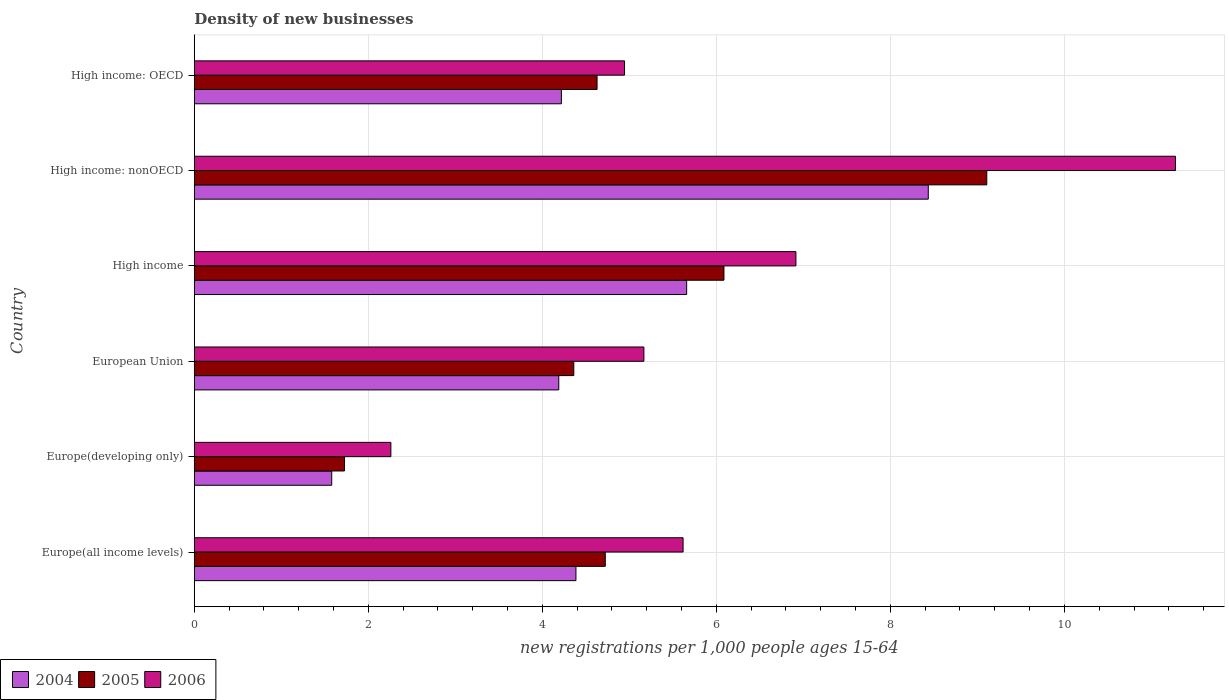How many different coloured bars are there?
Provide a short and direct response. 3. Are the number of bars per tick equal to the number of legend labels?
Give a very brief answer. Yes. Are the number of bars on each tick of the Y-axis equal?
Your answer should be very brief. Yes. What is the label of the 5th group of bars from the top?
Offer a very short reply. Europe(developing only). What is the number of new registrations in 2004 in European Union?
Give a very brief answer. 4.19. Across all countries, what is the maximum number of new registrations in 2004?
Offer a very short reply. 8.44. Across all countries, what is the minimum number of new registrations in 2004?
Your response must be concise. 1.58. In which country was the number of new registrations in 2006 maximum?
Keep it short and to the point. High income: nonOECD. In which country was the number of new registrations in 2006 minimum?
Your answer should be very brief. Europe(developing only). What is the total number of new registrations in 2006 in the graph?
Provide a short and direct response. 36.18. What is the difference between the number of new registrations in 2004 in Europe(developing only) and that in European Union?
Your answer should be compact. -2.61. What is the difference between the number of new registrations in 2004 in European Union and the number of new registrations in 2006 in High income?
Your answer should be compact. -2.73. What is the average number of new registrations in 2006 per country?
Make the answer very short. 6.03. What is the difference between the number of new registrations in 2004 and number of new registrations in 2006 in Europe(all income levels)?
Offer a terse response. -1.23. In how many countries, is the number of new registrations in 2004 greater than 2.8 ?
Your response must be concise. 5. What is the ratio of the number of new registrations in 2005 in Europe(developing only) to that in High income: OECD?
Provide a short and direct response. 0.37. Is the number of new registrations in 2006 in Europe(all income levels) less than that in Europe(developing only)?
Your response must be concise. No. What is the difference between the highest and the second highest number of new registrations in 2005?
Provide a short and direct response. 3.02. What is the difference between the highest and the lowest number of new registrations in 2005?
Your answer should be compact. 7.38. In how many countries, is the number of new registrations in 2005 greater than the average number of new registrations in 2005 taken over all countries?
Offer a very short reply. 2. What does the 3rd bar from the bottom in Europe(all income levels) represents?
Your answer should be compact. 2006. Is it the case that in every country, the sum of the number of new registrations in 2006 and number of new registrations in 2004 is greater than the number of new registrations in 2005?
Provide a succinct answer. Yes. Are all the bars in the graph horizontal?
Your answer should be very brief. Yes. How many countries are there in the graph?
Offer a terse response. 6. What is the difference between two consecutive major ticks on the X-axis?
Give a very brief answer. 2. Does the graph contain any zero values?
Ensure brevity in your answer.  No. Does the graph contain grids?
Give a very brief answer. Yes. How many legend labels are there?
Your answer should be very brief. 3. What is the title of the graph?
Make the answer very short. Density of new businesses. What is the label or title of the X-axis?
Give a very brief answer. New registrations per 1,0 people ages 15-64. What is the label or title of the Y-axis?
Make the answer very short. Country. What is the new registrations per 1,000 people ages 15-64 in 2004 in Europe(all income levels)?
Make the answer very short. 4.39. What is the new registrations per 1,000 people ages 15-64 of 2005 in Europe(all income levels)?
Ensure brevity in your answer.  4.72. What is the new registrations per 1,000 people ages 15-64 in 2006 in Europe(all income levels)?
Offer a very short reply. 5.62. What is the new registrations per 1,000 people ages 15-64 of 2004 in Europe(developing only)?
Your answer should be compact. 1.58. What is the new registrations per 1,000 people ages 15-64 of 2005 in Europe(developing only)?
Offer a terse response. 1.73. What is the new registrations per 1,000 people ages 15-64 of 2006 in Europe(developing only)?
Give a very brief answer. 2.26. What is the new registrations per 1,000 people ages 15-64 in 2004 in European Union?
Your response must be concise. 4.19. What is the new registrations per 1,000 people ages 15-64 in 2005 in European Union?
Your answer should be compact. 4.36. What is the new registrations per 1,000 people ages 15-64 of 2006 in European Union?
Provide a short and direct response. 5.17. What is the new registrations per 1,000 people ages 15-64 in 2004 in High income?
Provide a succinct answer. 5.66. What is the new registrations per 1,000 people ages 15-64 of 2005 in High income?
Your response must be concise. 6.09. What is the new registrations per 1,000 people ages 15-64 of 2006 in High income?
Your response must be concise. 6.91. What is the new registrations per 1,000 people ages 15-64 in 2004 in High income: nonOECD?
Your answer should be compact. 8.44. What is the new registrations per 1,000 people ages 15-64 in 2005 in High income: nonOECD?
Give a very brief answer. 9.11. What is the new registrations per 1,000 people ages 15-64 in 2006 in High income: nonOECD?
Offer a very short reply. 11.28. What is the new registrations per 1,000 people ages 15-64 in 2004 in High income: OECD?
Your answer should be very brief. 4.22. What is the new registrations per 1,000 people ages 15-64 of 2005 in High income: OECD?
Give a very brief answer. 4.63. What is the new registrations per 1,000 people ages 15-64 in 2006 in High income: OECD?
Keep it short and to the point. 4.94. Across all countries, what is the maximum new registrations per 1,000 people ages 15-64 of 2004?
Keep it short and to the point. 8.44. Across all countries, what is the maximum new registrations per 1,000 people ages 15-64 in 2005?
Keep it short and to the point. 9.11. Across all countries, what is the maximum new registrations per 1,000 people ages 15-64 in 2006?
Offer a very short reply. 11.28. Across all countries, what is the minimum new registrations per 1,000 people ages 15-64 of 2004?
Offer a very short reply. 1.58. Across all countries, what is the minimum new registrations per 1,000 people ages 15-64 in 2005?
Your response must be concise. 1.73. Across all countries, what is the minimum new registrations per 1,000 people ages 15-64 of 2006?
Make the answer very short. 2.26. What is the total new registrations per 1,000 people ages 15-64 of 2004 in the graph?
Provide a succinct answer. 28.47. What is the total new registrations per 1,000 people ages 15-64 in 2005 in the graph?
Offer a terse response. 30.64. What is the total new registrations per 1,000 people ages 15-64 of 2006 in the graph?
Give a very brief answer. 36.18. What is the difference between the new registrations per 1,000 people ages 15-64 of 2004 in Europe(all income levels) and that in Europe(developing only)?
Keep it short and to the point. 2.81. What is the difference between the new registrations per 1,000 people ages 15-64 in 2005 in Europe(all income levels) and that in Europe(developing only)?
Your answer should be compact. 3. What is the difference between the new registrations per 1,000 people ages 15-64 of 2006 in Europe(all income levels) and that in Europe(developing only)?
Provide a short and direct response. 3.36. What is the difference between the new registrations per 1,000 people ages 15-64 in 2004 in Europe(all income levels) and that in European Union?
Provide a succinct answer. 0.2. What is the difference between the new registrations per 1,000 people ages 15-64 of 2005 in Europe(all income levels) and that in European Union?
Provide a succinct answer. 0.36. What is the difference between the new registrations per 1,000 people ages 15-64 of 2006 in Europe(all income levels) and that in European Union?
Give a very brief answer. 0.45. What is the difference between the new registrations per 1,000 people ages 15-64 of 2004 in Europe(all income levels) and that in High income?
Give a very brief answer. -1.27. What is the difference between the new registrations per 1,000 people ages 15-64 in 2005 in Europe(all income levels) and that in High income?
Ensure brevity in your answer.  -1.36. What is the difference between the new registrations per 1,000 people ages 15-64 in 2006 in Europe(all income levels) and that in High income?
Provide a succinct answer. -1.3. What is the difference between the new registrations per 1,000 people ages 15-64 in 2004 in Europe(all income levels) and that in High income: nonOECD?
Ensure brevity in your answer.  -4.05. What is the difference between the new registrations per 1,000 people ages 15-64 of 2005 in Europe(all income levels) and that in High income: nonOECD?
Ensure brevity in your answer.  -4.38. What is the difference between the new registrations per 1,000 people ages 15-64 in 2006 in Europe(all income levels) and that in High income: nonOECD?
Your answer should be compact. -5.66. What is the difference between the new registrations per 1,000 people ages 15-64 in 2004 in Europe(all income levels) and that in High income: OECD?
Provide a succinct answer. 0.17. What is the difference between the new registrations per 1,000 people ages 15-64 in 2005 in Europe(all income levels) and that in High income: OECD?
Keep it short and to the point. 0.09. What is the difference between the new registrations per 1,000 people ages 15-64 in 2006 in Europe(all income levels) and that in High income: OECD?
Your answer should be very brief. 0.67. What is the difference between the new registrations per 1,000 people ages 15-64 in 2004 in Europe(developing only) and that in European Union?
Provide a short and direct response. -2.61. What is the difference between the new registrations per 1,000 people ages 15-64 in 2005 in Europe(developing only) and that in European Union?
Ensure brevity in your answer.  -2.64. What is the difference between the new registrations per 1,000 people ages 15-64 in 2006 in Europe(developing only) and that in European Union?
Your response must be concise. -2.91. What is the difference between the new registrations per 1,000 people ages 15-64 in 2004 in Europe(developing only) and that in High income?
Your answer should be very brief. -4.08. What is the difference between the new registrations per 1,000 people ages 15-64 of 2005 in Europe(developing only) and that in High income?
Ensure brevity in your answer.  -4.36. What is the difference between the new registrations per 1,000 people ages 15-64 of 2006 in Europe(developing only) and that in High income?
Keep it short and to the point. -4.66. What is the difference between the new registrations per 1,000 people ages 15-64 in 2004 in Europe(developing only) and that in High income: nonOECD?
Provide a succinct answer. -6.86. What is the difference between the new registrations per 1,000 people ages 15-64 in 2005 in Europe(developing only) and that in High income: nonOECD?
Your answer should be very brief. -7.38. What is the difference between the new registrations per 1,000 people ages 15-64 in 2006 in Europe(developing only) and that in High income: nonOECD?
Keep it short and to the point. -9.02. What is the difference between the new registrations per 1,000 people ages 15-64 in 2004 in Europe(developing only) and that in High income: OECD?
Ensure brevity in your answer.  -2.64. What is the difference between the new registrations per 1,000 people ages 15-64 of 2005 in Europe(developing only) and that in High income: OECD?
Your answer should be very brief. -2.9. What is the difference between the new registrations per 1,000 people ages 15-64 in 2006 in Europe(developing only) and that in High income: OECD?
Your response must be concise. -2.69. What is the difference between the new registrations per 1,000 people ages 15-64 of 2004 in European Union and that in High income?
Give a very brief answer. -1.47. What is the difference between the new registrations per 1,000 people ages 15-64 in 2005 in European Union and that in High income?
Ensure brevity in your answer.  -1.73. What is the difference between the new registrations per 1,000 people ages 15-64 in 2006 in European Union and that in High income?
Your answer should be very brief. -1.75. What is the difference between the new registrations per 1,000 people ages 15-64 in 2004 in European Union and that in High income: nonOECD?
Your response must be concise. -4.25. What is the difference between the new registrations per 1,000 people ages 15-64 of 2005 in European Union and that in High income: nonOECD?
Offer a very short reply. -4.75. What is the difference between the new registrations per 1,000 people ages 15-64 in 2006 in European Union and that in High income: nonOECD?
Your answer should be very brief. -6.11. What is the difference between the new registrations per 1,000 people ages 15-64 of 2004 in European Union and that in High income: OECD?
Ensure brevity in your answer.  -0.03. What is the difference between the new registrations per 1,000 people ages 15-64 in 2005 in European Union and that in High income: OECD?
Your answer should be very brief. -0.27. What is the difference between the new registrations per 1,000 people ages 15-64 in 2006 in European Union and that in High income: OECD?
Give a very brief answer. 0.22. What is the difference between the new registrations per 1,000 people ages 15-64 of 2004 in High income and that in High income: nonOECD?
Your answer should be compact. -2.78. What is the difference between the new registrations per 1,000 people ages 15-64 of 2005 in High income and that in High income: nonOECD?
Provide a short and direct response. -3.02. What is the difference between the new registrations per 1,000 people ages 15-64 of 2006 in High income and that in High income: nonOECD?
Offer a very short reply. -4.36. What is the difference between the new registrations per 1,000 people ages 15-64 in 2004 in High income and that in High income: OECD?
Make the answer very short. 1.44. What is the difference between the new registrations per 1,000 people ages 15-64 of 2005 in High income and that in High income: OECD?
Keep it short and to the point. 1.46. What is the difference between the new registrations per 1,000 people ages 15-64 of 2006 in High income and that in High income: OECD?
Make the answer very short. 1.97. What is the difference between the new registrations per 1,000 people ages 15-64 of 2004 in High income: nonOECD and that in High income: OECD?
Ensure brevity in your answer.  4.22. What is the difference between the new registrations per 1,000 people ages 15-64 of 2005 in High income: nonOECD and that in High income: OECD?
Your response must be concise. 4.48. What is the difference between the new registrations per 1,000 people ages 15-64 in 2006 in High income: nonOECD and that in High income: OECD?
Provide a succinct answer. 6.33. What is the difference between the new registrations per 1,000 people ages 15-64 in 2004 in Europe(all income levels) and the new registrations per 1,000 people ages 15-64 in 2005 in Europe(developing only)?
Make the answer very short. 2.66. What is the difference between the new registrations per 1,000 people ages 15-64 of 2004 in Europe(all income levels) and the new registrations per 1,000 people ages 15-64 of 2006 in Europe(developing only)?
Your answer should be compact. 2.13. What is the difference between the new registrations per 1,000 people ages 15-64 in 2005 in Europe(all income levels) and the new registrations per 1,000 people ages 15-64 in 2006 in Europe(developing only)?
Ensure brevity in your answer.  2.46. What is the difference between the new registrations per 1,000 people ages 15-64 in 2004 in Europe(all income levels) and the new registrations per 1,000 people ages 15-64 in 2005 in European Union?
Offer a terse response. 0.02. What is the difference between the new registrations per 1,000 people ages 15-64 in 2004 in Europe(all income levels) and the new registrations per 1,000 people ages 15-64 in 2006 in European Union?
Your answer should be very brief. -0.78. What is the difference between the new registrations per 1,000 people ages 15-64 in 2005 in Europe(all income levels) and the new registrations per 1,000 people ages 15-64 in 2006 in European Union?
Give a very brief answer. -0.44. What is the difference between the new registrations per 1,000 people ages 15-64 in 2004 in Europe(all income levels) and the new registrations per 1,000 people ages 15-64 in 2005 in High income?
Your answer should be compact. -1.7. What is the difference between the new registrations per 1,000 people ages 15-64 of 2004 in Europe(all income levels) and the new registrations per 1,000 people ages 15-64 of 2006 in High income?
Provide a short and direct response. -2.53. What is the difference between the new registrations per 1,000 people ages 15-64 of 2005 in Europe(all income levels) and the new registrations per 1,000 people ages 15-64 of 2006 in High income?
Provide a succinct answer. -2.19. What is the difference between the new registrations per 1,000 people ages 15-64 of 2004 in Europe(all income levels) and the new registrations per 1,000 people ages 15-64 of 2005 in High income: nonOECD?
Ensure brevity in your answer.  -4.72. What is the difference between the new registrations per 1,000 people ages 15-64 in 2004 in Europe(all income levels) and the new registrations per 1,000 people ages 15-64 in 2006 in High income: nonOECD?
Your answer should be very brief. -6.89. What is the difference between the new registrations per 1,000 people ages 15-64 of 2005 in Europe(all income levels) and the new registrations per 1,000 people ages 15-64 of 2006 in High income: nonOECD?
Give a very brief answer. -6.55. What is the difference between the new registrations per 1,000 people ages 15-64 in 2004 in Europe(all income levels) and the new registrations per 1,000 people ages 15-64 in 2005 in High income: OECD?
Ensure brevity in your answer.  -0.24. What is the difference between the new registrations per 1,000 people ages 15-64 of 2004 in Europe(all income levels) and the new registrations per 1,000 people ages 15-64 of 2006 in High income: OECD?
Provide a short and direct response. -0.56. What is the difference between the new registrations per 1,000 people ages 15-64 of 2005 in Europe(all income levels) and the new registrations per 1,000 people ages 15-64 of 2006 in High income: OECD?
Provide a short and direct response. -0.22. What is the difference between the new registrations per 1,000 people ages 15-64 of 2004 in Europe(developing only) and the new registrations per 1,000 people ages 15-64 of 2005 in European Union?
Offer a very short reply. -2.78. What is the difference between the new registrations per 1,000 people ages 15-64 in 2004 in Europe(developing only) and the new registrations per 1,000 people ages 15-64 in 2006 in European Union?
Give a very brief answer. -3.59. What is the difference between the new registrations per 1,000 people ages 15-64 of 2005 in Europe(developing only) and the new registrations per 1,000 people ages 15-64 of 2006 in European Union?
Offer a very short reply. -3.44. What is the difference between the new registrations per 1,000 people ages 15-64 of 2004 in Europe(developing only) and the new registrations per 1,000 people ages 15-64 of 2005 in High income?
Offer a very short reply. -4.51. What is the difference between the new registrations per 1,000 people ages 15-64 of 2004 in Europe(developing only) and the new registrations per 1,000 people ages 15-64 of 2006 in High income?
Provide a succinct answer. -5.33. What is the difference between the new registrations per 1,000 people ages 15-64 of 2005 in Europe(developing only) and the new registrations per 1,000 people ages 15-64 of 2006 in High income?
Your response must be concise. -5.19. What is the difference between the new registrations per 1,000 people ages 15-64 of 2004 in Europe(developing only) and the new registrations per 1,000 people ages 15-64 of 2005 in High income: nonOECD?
Give a very brief answer. -7.53. What is the difference between the new registrations per 1,000 people ages 15-64 of 2004 in Europe(developing only) and the new registrations per 1,000 people ages 15-64 of 2006 in High income: nonOECD?
Make the answer very short. -9.7. What is the difference between the new registrations per 1,000 people ages 15-64 in 2005 in Europe(developing only) and the new registrations per 1,000 people ages 15-64 in 2006 in High income: nonOECD?
Your response must be concise. -9.55. What is the difference between the new registrations per 1,000 people ages 15-64 in 2004 in Europe(developing only) and the new registrations per 1,000 people ages 15-64 in 2005 in High income: OECD?
Give a very brief answer. -3.05. What is the difference between the new registrations per 1,000 people ages 15-64 in 2004 in Europe(developing only) and the new registrations per 1,000 people ages 15-64 in 2006 in High income: OECD?
Your answer should be compact. -3.37. What is the difference between the new registrations per 1,000 people ages 15-64 of 2005 in Europe(developing only) and the new registrations per 1,000 people ages 15-64 of 2006 in High income: OECD?
Your answer should be compact. -3.22. What is the difference between the new registrations per 1,000 people ages 15-64 in 2004 in European Union and the new registrations per 1,000 people ages 15-64 in 2005 in High income?
Ensure brevity in your answer.  -1.9. What is the difference between the new registrations per 1,000 people ages 15-64 in 2004 in European Union and the new registrations per 1,000 people ages 15-64 in 2006 in High income?
Provide a short and direct response. -2.73. What is the difference between the new registrations per 1,000 people ages 15-64 of 2005 in European Union and the new registrations per 1,000 people ages 15-64 of 2006 in High income?
Your answer should be compact. -2.55. What is the difference between the new registrations per 1,000 people ages 15-64 of 2004 in European Union and the new registrations per 1,000 people ages 15-64 of 2005 in High income: nonOECD?
Your answer should be very brief. -4.92. What is the difference between the new registrations per 1,000 people ages 15-64 in 2004 in European Union and the new registrations per 1,000 people ages 15-64 in 2006 in High income: nonOECD?
Your answer should be very brief. -7.09. What is the difference between the new registrations per 1,000 people ages 15-64 in 2005 in European Union and the new registrations per 1,000 people ages 15-64 in 2006 in High income: nonOECD?
Provide a succinct answer. -6.91. What is the difference between the new registrations per 1,000 people ages 15-64 in 2004 in European Union and the new registrations per 1,000 people ages 15-64 in 2005 in High income: OECD?
Provide a succinct answer. -0.44. What is the difference between the new registrations per 1,000 people ages 15-64 of 2004 in European Union and the new registrations per 1,000 people ages 15-64 of 2006 in High income: OECD?
Offer a terse response. -0.76. What is the difference between the new registrations per 1,000 people ages 15-64 of 2005 in European Union and the new registrations per 1,000 people ages 15-64 of 2006 in High income: OECD?
Provide a short and direct response. -0.58. What is the difference between the new registrations per 1,000 people ages 15-64 in 2004 in High income and the new registrations per 1,000 people ages 15-64 in 2005 in High income: nonOECD?
Ensure brevity in your answer.  -3.45. What is the difference between the new registrations per 1,000 people ages 15-64 in 2004 in High income and the new registrations per 1,000 people ages 15-64 in 2006 in High income: nonOECD?
Make the answer very short. -5.62. What is the difference between the new registrations per 1,000 people ages 15-64 of 2005 in High income and the new registrations per 1,000 people ages 15-64 of 2006 in High income: nonOECD?
Your answer should be very brief. -5.19. What is the difference between the new registrations per 1,000 people ages 15-64 in 2004 in High income and the new registrations per 1,000 people ages 15-64 in 2005 in High income: OECD?
Ensure brevity in your answer.  1.03. What is the difference between the new registrations per 1,000 people ages 15-64 in 2004 in High income and the new registrations per 1,000 people ages 15-64 in 2006 in High income: OECD?
Ensure brevity in your answer.  0.71. What is the difference between the new registrations per 1,000 people ages 15-64 of 2005 in High income and the new registrations per 1,000 people ages 15-64 of 2006 in High income: OECD?
Ensure brevity in your answer.  1.14. What is the difference between the new registrations per 1,000 people ages 15-64 of 2004 in High income: nonOECD and the new registrations per 1,000 people ages 15-64 of 2005 in High income: OECD?
Provide a succinct answer. 3.81. What is the difference between the new registrations per 1,000 people ages 15-64 in 2004 in High income: nonOECD and the new registrations per 1,000 people ages 15-64 in 2006 in High income: OECD?
Your response must be concise. 3.49. What is the difference between the new registrations per 1,000 people ages 15-64 in 2005 in High income: nonOECD and the new registrations per 1,000 people ages 15-64 in 2006 in High income: OECD?
Provide a succinct answer. 4.16. What is the average new registrations per 1,000 people ages 15-64 of 2004 per country?
Your answer should be compact. 4.74. What is the average new registrations per 1,000 people ages 15-64 in 2005 per country?
Your response must be concise. 5.11. What is the average new registrations per 1,000 people ages 15-64 of 2006 per country?
Offer a very short reply. 6.03. What is the difference between the new registrations per 1,000 people ages 15-64 of 2004 and new registrations per 1,000 people ages 15-64 of 2005 in Europe(all income levels)?
Your answer should be compact. -0.34. What is the difference between the new registrations per 1,000 people ages 15-64 in 2004 and new registrations per 1,000 people ages 15-64 in 2006 in Europe(all income levels)?
Your response must be concise. -1.23. What is the difference between the new registrations per 1,000 people ages 15-64 of 2005 and new registrations per 1,000 people ages 15-64 of 2006 in Europe(all income levels)?
Your answer should be very brief. -0.89. What is the difference between the new registrations per 1,000 people ages 15-64 in 2004 and new registrations per 1,000 people ages 15-64 in 2005 in Europe(developing only)?
Give a very brief answer. -0.15. What is the difference between the new registrations per 1,000 people ages 15-64 of 2004 and new registrations per 1,000 people ages 15-64 of 2006 in Europe(developing only)?
Keep it short and to the point. -0.68. What is the difference between the new registrations per 1,000 people ages 15-64 of 2005 and new registrations per 1,000 people ages 15-64 of 2006 in Europe(developing only)?
Your answer should be compact. -0.53. What is the difference between the new registrations per 1,000 people ages 15-64 in 2004 and new registrations per 1,000 people ages 15-64 in 2005 in European Union?
Make the answer very short. -0.17. What is the difference between the new registrations per 1,000 people ages 15-64 in 2004 and new registrations per 1,000 people ages 15-64 in 2006 in European Union?
Your answer should be very brief. -0.98. What is the difference between the new registrations per 1,000 people ages 15-64 in 2005 and new registrations per 1,000 people ages 15-64 in 2006 in European Union?
Give a very brief answer. -0.81. What is the difference between the new registrations per 1,000 people ages 15-64 of 2004 and new registrations per 1,000 people ages 15-64 of 2005 in High income?
Keep it short and to the point. -0.43. What is the difference between the new registrations per 1,000 people ages 15-64 in 2004 and new registrations per 1,000 people ages 15-64 in 2006 in High income?
Give a very brief answer. -1.26. What is the difference between the new registrations per 1,000 people ages 15-64 in 2005 and new registrations per 1,000 people ages 15-64 in 2006 in High income?
Ensure brevity in your answer.  -0.83. What is the difference between the new registrations per 1,000 people ages 15-64 in 2004 and new registrations per 1,000 people ages 15-64 in 2005 in High income: nonOECD?
Your response must be concise. -0.67. What is the difference between the new registrations per 1,000 people ages 15-64 of 2004 and new registrations per 1,000 people ages 15-64 of 2006 in High income: nonOECD?
Offer a terse response. -2.84. What is the difference between the new registrations per 1,000 people ages 15-64 in 2005 and new registrations per 1,000 people ages 15-64 in 2006 in High income: nonOECD?
Keep it short and to the point. -2.17. What is the difference between the new registrations per 1,000 people ages 15-64 in 2004 and new registrations per 1,000 people ages 15-64 in 2005 in High income: OECD?
Your response must be concise. -0.41. What is the difference between the new registrations per 1,000 people ages 15-64 of 2004 and new registrations per 1,000 people ages 15-64 of 2006 in High income: OECD?
Your answer should be compact. -0.73. What is the difference between the new registrations per 1,000 people ages 15-64 of 2005 and new registrations per 1,000 people ages 15-64 of 2006 in High income: OECD?
Give a very brief answer. -0.32. What is the ratio of the new registrations per 1,000 people ages 15-64 in 2004 in Europe(all income levels) to that in Europe(developing only)?
Keep it short and to the point. 2.78. What is the ratio of the new registrations per 1,000 people ages 15-64 of 2005 in Europe(all income levels) to that in Europe(developing only)?
Your answer should be very brief. 2.74. What is the ratio of the new registrations per 1,000 people ages 15-64 of 2006 in Europe(all income levels) to that in Europe(developing only)?
Your answer should be compact. 2.49. What is the ratio of the new registrations per 1,000 people ages 15-64 of 2004 in Europe(all income levels) to that in European Union?
Your answer should be very brief. 1.05. What is the ratio of the new registrations per 1,000 people ages 15-64 in 2005 in Europe(all income levels) to that in European Union?
Give a very brief answer. 1.08. What is the ratio of the new registrations per 1,000 people ages 15-64 in 2006 in Europe(all income levels) to that in European Union?
Offer a terse response. 1.09. What is the ratio of the new registrations per 1,000 people ages 15-64 in 2004 in Europe(all income levels) to that in High income?
Offer a terse response. 0.78. What is the ratio of the new registrations per 1,000 people ages 15-64 of 2005 in Europe(all income levels) to that in High income?
Ensure brevity in your answer.  0.78. What is the ratio of the new registrations per 1,000 people ages 15-64 in 2006 in Europe(all income levels) to that in High income?
Provide a succinct answer. 0.81. What is the ratio of the new registrations per 1,000 people ages 15-64 of 2004 in Europe(all income levels) to that in High income: nonOECD?
Offer a terse response. 0.52. What is the ratio of the new registrations per 1,000 people ages 15-64 of 2005 in Europe(all income levels) to that in High income: nonOECD?
Offer a terse response. 0.52. What is the ratio of the new registrations per 1,000 people ages 15-64 in 2006 in Europe(all income levels) to that in High income: nonOECD?
Offer a terse response. 0.5. What is the ratio of the new registrations per 1,000 people ages 15-64 of 2004 in Europe(all income levels) to that in High income: OECD?
Your response must be concise. 1.04. What is the ratio of the new registrations per 1,000 people ages 15-64 in 2005 in Europe(all income levels) to that in High income: OECD?
Offer a terse response. 1.02. What is the ratio of the new registrations per 1,000 people ages 15-64 in 2006 in Europe(all income levels) to that in High income: OECD?
Offer a terse response. 1.14. What is the ratio of the new registrations per 1,000 people ages 15-64 in 2004 in Europe(developing only) to that in European Union?
Offer a terse response. 0.38. What is the ratio of the new registrations per 1,000 people ages 15-64 in 2005 in Europe(developing only) to that in European Union?
Offer a terse response. 0.4. What is the ratio of the new registrations per 1,000 people ages 15-64 in 2006 in Europe(developing only) to that in European Union?
Give a very brief answer. 0.44. What is the ratio of the new registrations per 1,000 people ages 15-64 in 2004 in Europe(developing only) to that in High income?
Provide a short and direct response. 0.28. What is the ratio of the new registrations per 1,000 people ages 15-64 of 2005 in Europe(developing only) to that in High income?
Give a very brief answer. 0.28. What is the ratio of the new registrations per 1,000 people ages 15-64 of 2006 in Europe(developing only) to that in High income?
Keep it short and to the point. 0.33. What is the ratio of the new registrations per 1,000 people ages 15-64 of 2004 in Europe(developing only) to that in High income: nonOECD?
Offer a very short reply. 0.19. What is the ratio of the new registrations per 1,000 people ages 15-64 in 2005 in Europe(developing only) to that in High income: nonOECD?
Make the answer very short. 0.19. What is the ratio of the new registrations per 1,000 people ages 15-64 in 2006 in Europe(developing only) to that in High income: nonOECD?
Offer a terse response. 0.2. What is the ratio of the new registrations per 1,000 people ages 15-64 of 2004 in Europe(developing only) to that in High income: OECD?
Offer a terse response. 0.37. What is the ratio of the new registrations per 1,000 people ages 15-64 in 2005 in Europe(developing only) to that in High income: OECD?
Offer a very short reply. 0.37. What is the ratio of the new registrations per 1,000 people ages 15-64 of 2006 in Europe(developing only) to that in High income: OECD?
Your answer should be compact. 0.46. What is the ratio of the new registrations per 1,000 people ages 15-64 of 2004 in European Union to that in High income?
Your answer should be compact. 0.74. What is the ratio of the new registrations per 1,000 people ages 15-64 of 2005 in European Union to that in High income?
Your answer should be very brief. 0.72. What is the ratio of the new registrations per 1,000 people ages 15-64 in 2006 in European Union to that in High income?
Give a very brief answer. 0.75. What is the ratio of the new registrations per 1,000 people ages 15-64 of 2004 in European Union to that in High income: nonOECD?
Your answer should be very brief. 0.5. What is the ratio of the new registrations per 1,000 people ages 15-64 of 2005 in European Union to that in High income: nonOECD?
Offer a very short reply. 0.48. What is the ratio of the new registrations per 1,000 people ages 15-64 in 2006 in European Union to that in High income: nonOECD?
Provide a succinct answer. 0.46. What is the ratio of the new registrations per 1,000 people ages 15-64 of 2004 in European Union to that in High income: OECD?
Ensure brevity in your answer.  0.99. What is the ratio of the new registrations per 1,000 people ages 15-64 in 2005 in European Union to that in High income: OECD?
Your response must be concise. 0.94. What is the ratio of the new registrations per 1,000 people ages 15-64 of 2006 in European Union to that in High income: OECD?
Give a very brief answer. 1.04. What is the ratio of the new registrations per 1,000 people ages 15-64 of 2004 in High income to that in High income: nonOECD?
Your answer should be compact. 0.67. What is the ratio of the new registrations per 1,000 people ages 15-64 of 2005 in High income to that in High income: nonOECD?
Your response must be concise. 0.67. What is the ratio of the new registrations per 1,000 people ages 15-64 of 2006 in High income to that in High income: nonOECD?
Ensure brevity in your answer.  0.61. What is the ratio of the new registrations per 1,000 people ages 15-64 in 2004 in High income to that in High income: OECD?
Provide a succinct answer. 1.34. What is the ratio of the new registrations per 1,000 people ages 15-64 of 2005 in High income to that in High income: OECD?
Provide a succinct answer. 1.31. What is the ratio of the new registrations per 1,000 people ages 15-64 of 2006 in High income to that in High income: OECD?
Provide a succinct answer. 1.4. What is the ratio of the new registrations per 1,000 people ages 15-64 in 2004 in High income: nonOECD to that in High income: OECD?
Offer a very short reply. 2. What is the ratio of the new registrations per 1,000 people ages 15-64 of 2005 in High income: nonOECD to that in High income: OECD?
Your answer should be very brief. 1.97. What is the ratio of the new registrations per 1,000 people ages 15-64 of 2006 in High income: nonOECD to that in High income: OECD?
Provide a succinct answer. 2.28. What is the difference between the highest and the second highest new registrations per 1,000 people ages 15-64 of 2004?
Provide a succinct answer. 2.78. What is the difference between the highest and the second highest new registrations per 1,000 people ages 15-64 in 2005?
Ensure brevity in your answer.  3.02. What is the difference between the highest and the second highest new registrations per 1,000 people ages 15-64 in 2006?
Make the answer very short. 4.36. What is the difference between the highest and the lowest new registrations per 1,000 people ages 15-64 of 2004?
Keep it short and to the point. 6.86. What is the difference between the highest and the lowest new registrations per 1,000 people ages 15-64 of 2005?
Provide a short and direct response. 7.38. What is the difference between the highest and the lowest new registrations per 1,000 people ages 15-64 of 2006?
Your response must be concise. 9.02. 